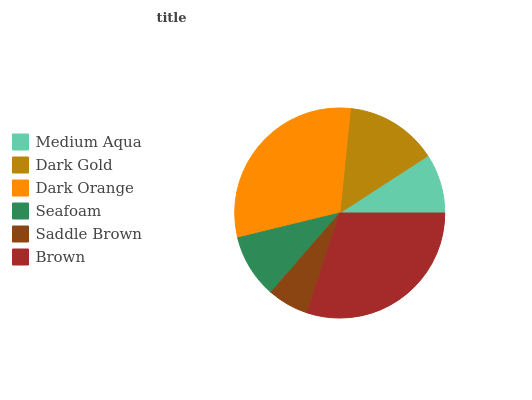Is Saddle Brown the minimum?
Answer yes or no. Yes. Is Dark Orange the maximum?
Answer yes or no. Yes. Is Dark Gold the minimum?
Answer yes or no. No. Is Dark Gold the maximum?
Answer yes or no. No. Is Dark Gold greater than Medium Aqua?
Answer yes or no. Yes. Is Medium Aqua less than Dark Gold?
Answer yes or no. Yes. Is Medium Aqua greater than Dark Gold?
Answer yes or no. No. Is Dark Gold less than Medium Aqua?
Answer yes or no. No. Is Dark Gold the high median?
Answer yes or no. Yes. Is Seafoam the low median?
Answer yes or no. Yes. Is Medium Aqua the high median?
Answer yes or no. No. Is Brown the low median?
Answer yes or no. No. 